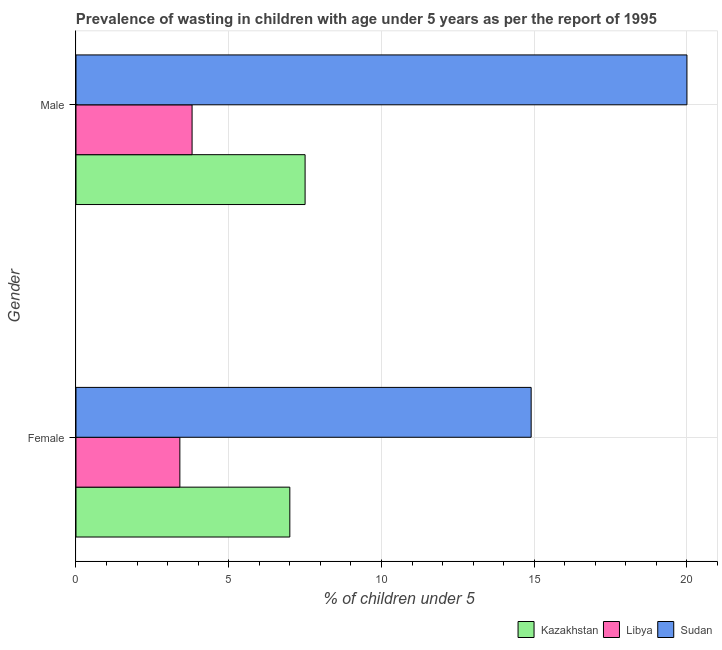How many different coloured bars are there?
Provide a short and direct response. 3. Are the number of bars per tick equal to the number of legend labels?
Offer a terse response. Yes. What is the label of the 1st group of bars from the top?
Your response must be concise. Male. Across all countries, what is the maximum percentage of undernourished female children?
Your response must be concise. 14.9. Across all countries, what is the minimum percentage of undernourished male children?
Offer a very short reply. 3.8. In which country was the percentage of undernourished female children maximum?
Keep it short and to the point. Sudan. In which country was the percentage of undernourished male children minimum?
Your answer should be very brief. Libya. What is the total percentage of undernourished male children in the graph?
Make the answer very short. 31.3. What is the difference between the percentage of undernourished female children in Sudan and that in Libya?
Offer a very short reply. 11.5. What is the difference between the percentage of undernourished male children in Libya and the percentage of undernourished female children in Kazakhstan?
Keep it short and to the point. -3.2. What is the average percentage of undernourished female children per country?
Make the answer very short. 8.43. What is the difference between the percentage of undernourished male children and percentage of undernourished female children in Sudan?
Offer a very short reply. 5.1. What is the ratio of the percentage of undernourished male children in Libya to that in Sudan?
Offer a very short reply. 0.19. What does the 3rd bar from the top in Male represents?
Your response must be concise. Kazakhstan. What does the 3rd bar from the bottom in Female represents?
Your response must be concise. Sudan. Are all the bars in the graph horizontal?
Keep it short and to the point. Yes. Where does the legend appear in the graph?
Your response must be concise. Bottom right. What is the title of the graph?
Your answer should be compact. Prevalence of wasting in children with age under 5 years as per the report of 1995. Does "Lebanon" appear as one of the legend labels in the graph?
Offer a terse response. No. What is the label or title of the X-axis?
Your response must be concise.  % of children under 5. What is the label or title of the Y-axis?
Provide a succinct answer. Gender. What is the  % of children under 5 of Kazakhstan in Female?
Your response must be concise. 7. What is the  % of children under 5 in Libya in Female?
Offer a very short reply. 3.4. What is the  % of children under 5 of Sudan in Female?
Ensure brevity in your answer.  14.9. What is the  % of children under 5 in Kazakhstan in Male?
Your answer should be very brief. 7.5. What is the  % of children under 5 of Libya in Male?
Keep it short and to the point. 3.8. What is the  % of children under 5 in Sudan in Male?
Provide a succinct answer. 20. Across all Gender, what is the maximum  % of children under 5 of Libya?
Keep it short and to the point. 3.8. Across all Gender, what is the maximum  % of children under 5 of Sudan?
Provide a succinct answer. 20. Across all Gender, what is the minimum  % of children under 5 of Libya?
Your answer should be compact. 3.4. Across all Gender, what is the minimum  % of children under 5 of Sudan?
Your answer should be compact. 14.9. What is the total  % of children under 5 of Kazakhstan in the graph?
Keep it short and to the point. 14.5. What is the total  % of children under 5 in Sudan in the graph?
Your answer should be very brief. 34.9. What is the difference between the  % of children under 5 of Kazakhstan in Female and that in Male?
Keep it short and to the point. -0.5. What is the difference between the  % of children under 5 of Libya in Female and that in Male?
Offer a terse response. -0.4. What is the difference between the  % of children under 5 in Sudan in Female and that in Male?
Your response must be concise. -5.1. What is the difference between the  % of children under 5 in Kazakhstan in Female and the  % of children under 5 in Libya in Male?
Your response must be concise. 3.2. What is the difference between the  % of children under 5 of Kazakhstan in Female and the  % of children under 5 of Sudan in Male?
Make the answer very short. -13. What is the difference between the  % of children under 5 in Libya in Female and the  % of children under 5 in Sudan in Male?
Provide a short and direct response. -16.6. What is the average  % of children under 5 in Kazakhstan per Gender?
Offer a very short reply. 7.25. What is the average  % of children under 5 of Libya per Gender?
Offer a terse response. 3.6. What is the average  % of children under 5 of Sudan per Gender?
Offer a terse response. 17.45. What is the difference between the  % of children under 5 in Kazakhstan and  % of children under 5 in Sudan in Female?
Provide a short and direct response. -7.9. What is the difference between the  % of children under 5 of Libya and  % of children under 5 of Sudan in Female?
Ensure brevity in your answer.  -11.5. What is the difference between the  % of children under 5 of Kazakhstan and  % of children under 5 of Libya in Male?
Provide a succinct answer. 3.7. What is the difference between the  % of children under 5 of Libya and  % of children under 5 of Sudan in Male?
Offer a terse response. -16.2. What is the ratio of the  % of children under 5 of Kazakhstan in Female to that in Male?
Offer a very short reply. 0.93. What is the ratio of the  % of children under 5 of Libya in Female to that in Male?
Keep it short and to the point. 0.89. What is the ratio of the  % of children under 5 in Sudan in Female to that in Male?
Make the answer very short. 0.74. What is the difference between the highest and the lowest  % of children under 5 in Kazakhstan?
Keep it short and to the point. 0.5. What is the difference between the highest and the lowest  % of children under 5 of Libya?
Make the answer very short. 0.4. What is the difference between the highest and the lowest  % of children under 5 in Sudan?
Provide a short and direct response. 5.1. 